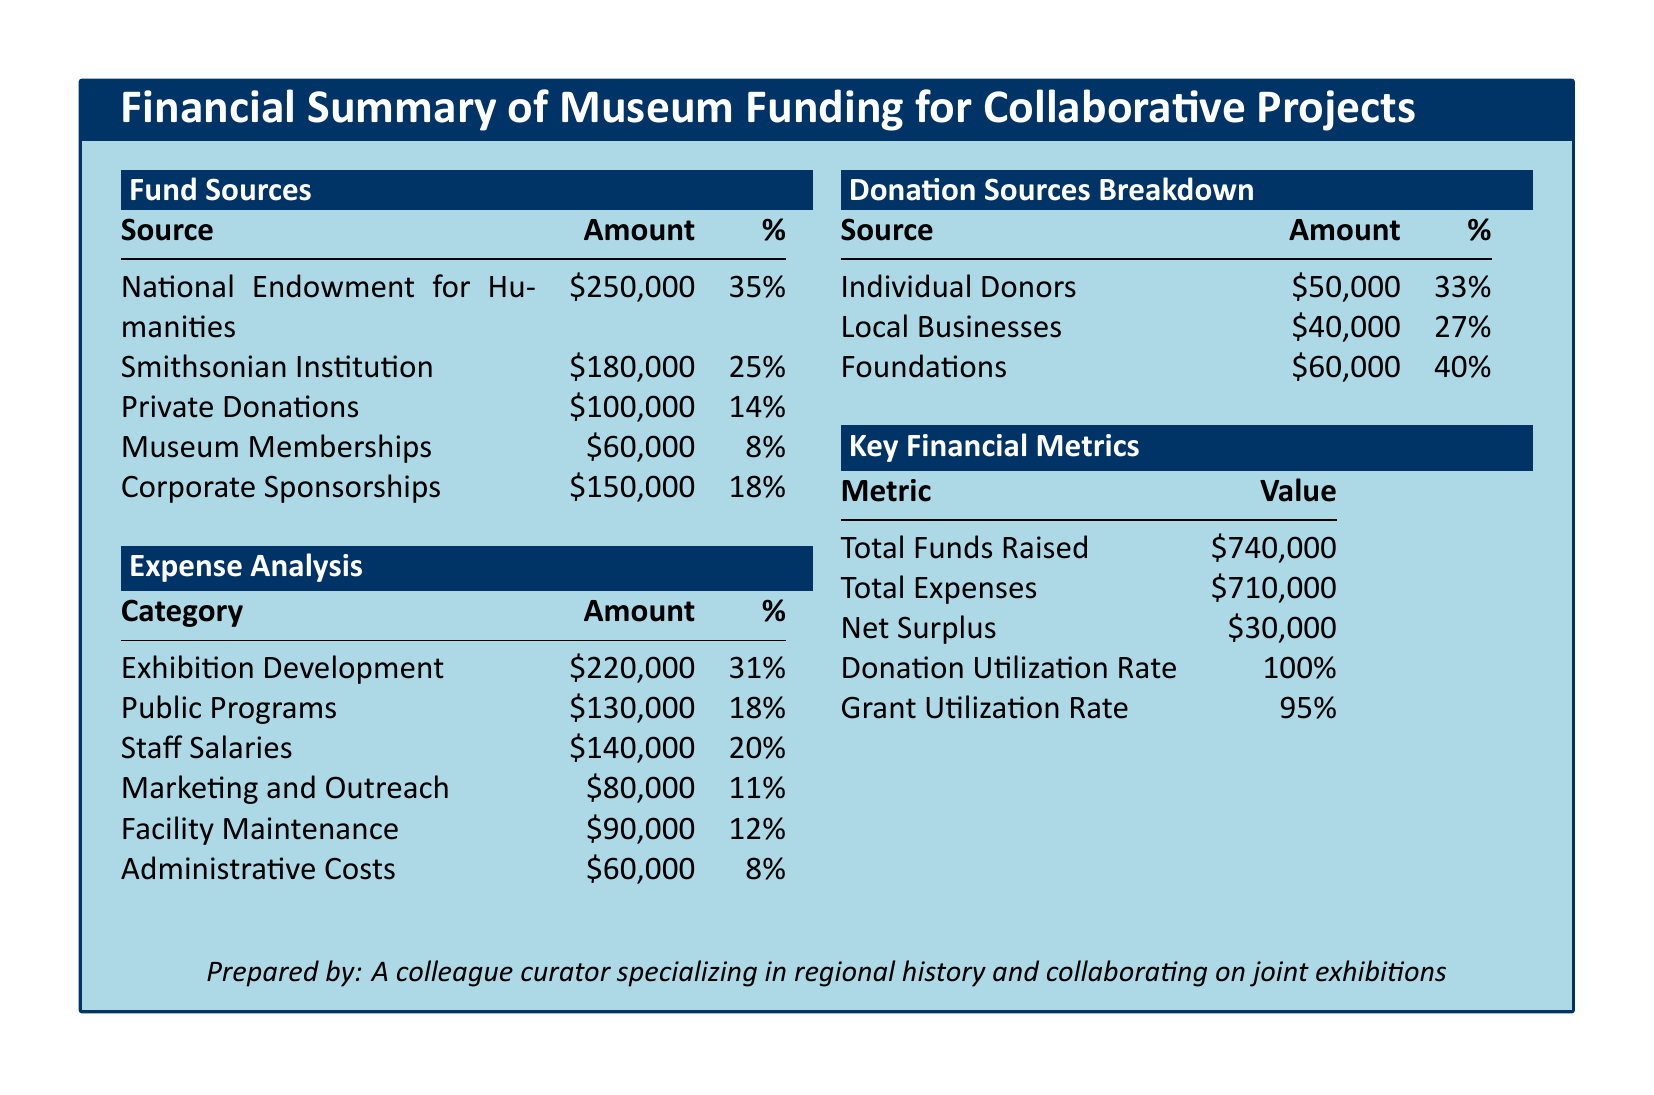what is the largest funding source? The largest funding source listed in the document is the National Endowment for Humanities, which contributed $250,000.
Answer: National Endowment for Humanities what percentage of total funds does Corporate Sponsorships represent? Corporate Sponsorships amount to $150,000, which is 18% of the total funds.
Answer: 18% what is the total amount raised from Private Donations? The document indicates that total Private Donations are $100,000.
Answer: $100,000 which expense category has the highest allocation? The highest expense allocation is for Exhibition Development, totaling $220,000.
Answer: Exhibition Development what is the donation utilization rate? The donation utilization rate specified in the document is 100%.
Answer: 100% how much surplus is reported in the financial summary? The document reports a net surplus of $30,000.
Answer: $30,000 what are total expenses for the Collaborative Projects? The total expenses for the Collaborative Projects amount to $710,000.
Answer: $710,000 how much funding did Foundations provide? Foundations provided a total of $60,000 in donations.
Answer: $60,000 what is the percentage for Public Programs expenses? Public Programs expenses account for 18% of the total expenses.
Answer: 18% 